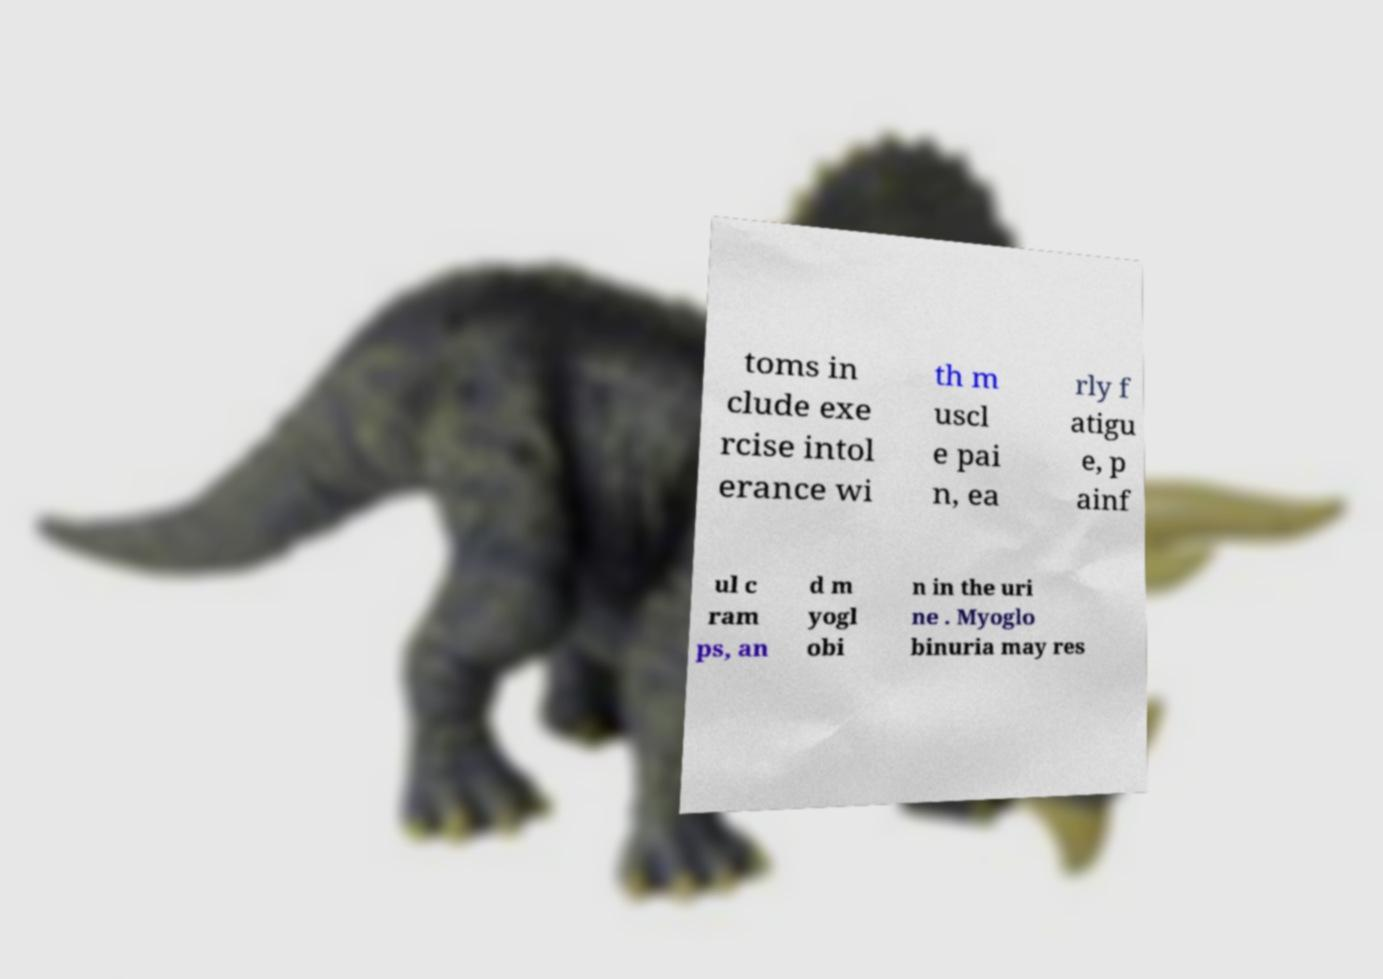What messages or text are displayed in this image? I need them in a readable, typed format. toms in clude exe rcise intol erance wi th m uscl e pai n, ea rly f atigu e, p ainf ul c ram ps, an d m yogl obi n in the uri ne . Myoglo binuria may res 